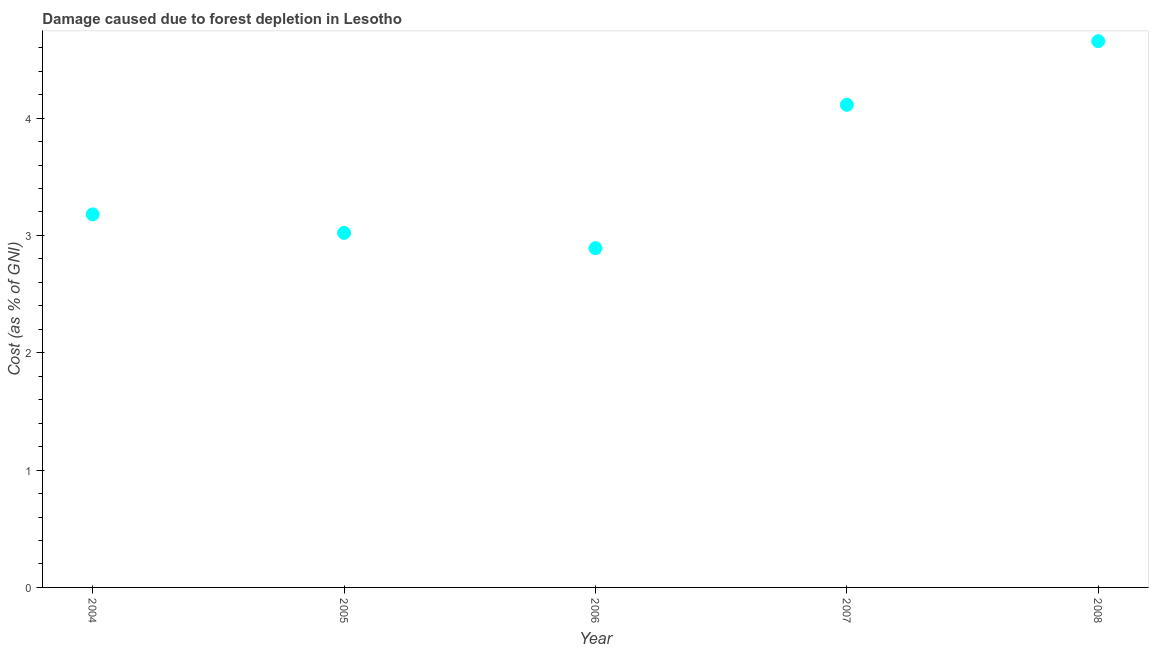What is the damage caused due to forest depletion in 2007?
Make the answer very short. 4.11. Across all years, what is the maximum damage caused due to forest depletion?
Your answer should be very brief. 4.66. Across all years, what is the minimum damage caused due to forest depletion?
Give a very brief answer. 2.89. In which year was the damage caused due to forest depletion maximum?
Provide a succinct answer. 2008. What is the sum of the damage caused due to forest depletion?
Provide a succinct answer. 17.86. What is the difference between the damage caused due to forest depletion in 2007 and 2008?
Offer a very short reply. -0.54. What is the average damage caused due to forest depletion per year?
Make the answer very short. 3.57. What is the median damage caused due to forest depletion?
Keep it short and to the point. 3.18. In how many years, is the damage caused due to forest depletion greater than 1 %?
Your answer should be compact. 5. Do a majority of the years between 2006 and 2005 (inclusive) have damage caused due to forest depletion greater than 2.8 %?
Offer a very short reply. No. What is the ratio of the damage caused due to forest depletion in 2006 to that in 2007?
Offer a very short reply. 0.7. Is the damage caused due to forest depletion in 2004 less than that in 2005?
Your response must be concise. No. Is the difference between the damage caused due to forest depletion in 2004 and 2007 greater than the difference between any two years?
Provide a short and direct response. No. What is the difference between the highest and the second highest damage caused due to forest depletion?
Offer a terse response. 0.54. What is the difference between the highest and the lowest damage caused due to forest depletion?
Make the answer very short. 1.76. In how many years, is the damage caused due to forest depletion greater than the average damage caused due to forest depletion taken over all years?
Provide a short and direct response. 2. Does the graph contain any zero values?
Your answer should be compact. No. What is the title of the graph?
Offer a very short reply. Damage caused due to forest depletion in Lesotho. What is the label or title of the X-axis?
Offer a very short reply. Year. What is the label or title of the Y-axis?
Your response must be concise. Cost (as % of GNI). What is the Cost (as % of GNI) in 2004?
Your response must be concise. 3.18. What is the Cost (as % of GNI) in 2005?
Your response must be concise. 3.02. What is the Cost (as % of GNI) in 2006?
Provide a short and direct response. 2.89. What is the Cost (as % of GNI) in 2007?
Offer a terse response. 4.11. What is the Cost (as % of GNI) in 2008?
Your answer should be very brief. 4.66. What is the difference between the Cost (as % of GNI) in 2004 and 2005?
Your response must be concise. 0.16. What is the difference between the Cost (as % of GNI) in 2004 and 2006?
Offer a terse response. 0.29. What is the difference between the Cost (as % of GNI) in 2004 and 2007?
Keep it short and to the point. -0.93. What is the difference between the Cost (as % of GNI) in 2004 and 2008?
Provide a succinct answer. -1.48. What is the difference between the Cost (as % of GNI) in 2005 and 2006?
Your answer should be very brief. 0.13. What is the difference between the Cost (as % of GNI) in 2005 and 2007?
Keep it short and to the point. -1.09. What is the difference between the Cost (as % of GNI) in 2005 and 2008?
Your answer should be compact. -1.63. What is the difference between the Cost (as % of GNI) in 2006 and 2007?
Provide a succinct answer. -1.22. What is the difference between the Cost (as % of GNI) in 2006 and 2008?
Offer a very short reply. -1.76. What is the difference between the Cost (as % of GNI) in 2007 and 2008?
Give a very brief answer. -0.54. What is the ratio of the Cost (as % of GNI) in 2004 to that in 2005?
Your response must be concise. 1.05. What is the ratio of the Cost (as % of GNI) in 2004 to that in 2007?
Your answer should be very brief. 0.77. What is the ratio of the Cost (as % of GNI) in 2004 to that in 2008?
Your response must be concise. 0.68. What is the ratio of the Cost (as % of GNI) in 2005 to that in 2006?
Make the answer very short. 1.04. What is the ratio of the Cost (as % of GNI) in 2005 to that in 2007?
Provide a short and direct response. 0.73. What is the ratio of the Cost (as % of GNI) in 2005 to that in 2008?
Your answer should be compact. 0.65. What is the ratio of the Cost (as % of GNI) in 2006 to that in 2007?
Provide a succinct answer. 0.7. What is the ratio of the Cost (as % of GNI) in 2006 to that in 2008?
Make the answer very short. 0.62. What is the ratio of the Cost (as % of GNI) in 2007 to that in 2008?
Your answer should be compact. 0.88. 